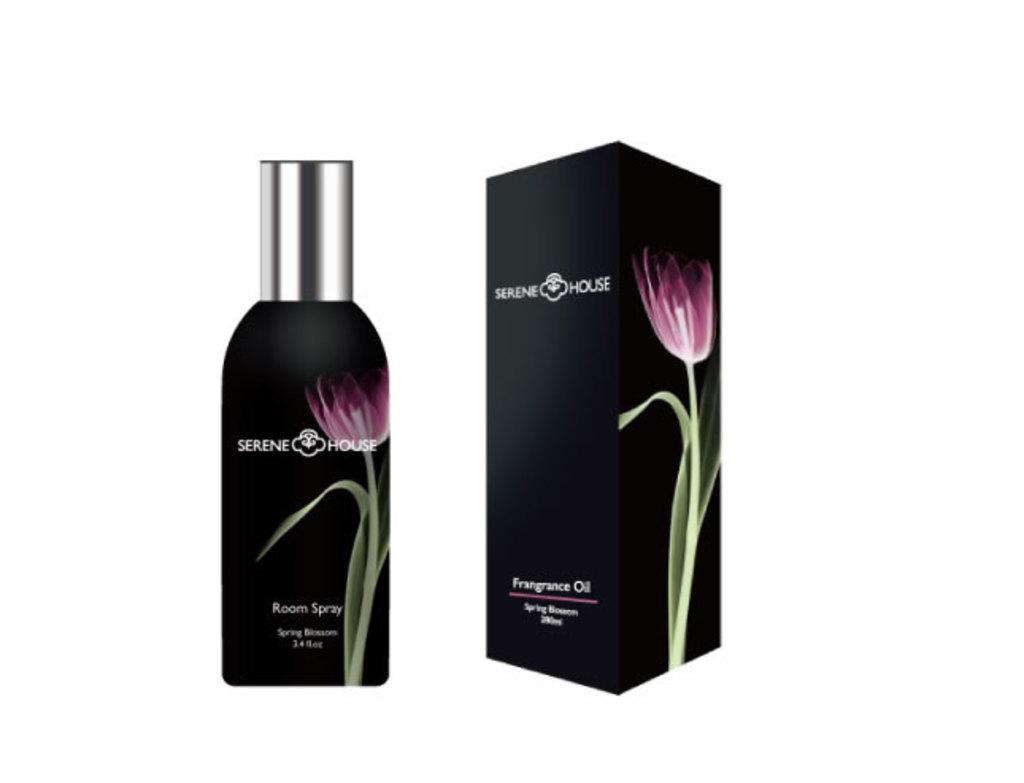What is the brand name?
Ensure brevity in your answer.  Serene house. 